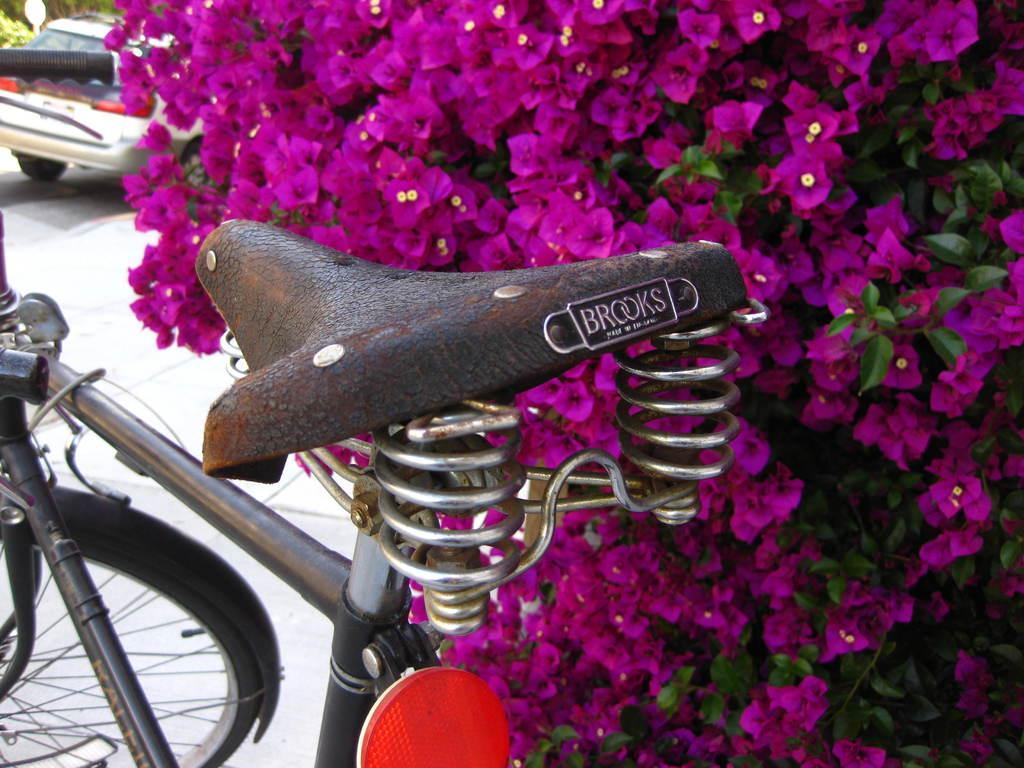Can you describe this image briefly? There is a cycle and behind the cycle there are pink flowers and in the left side there is a car. 